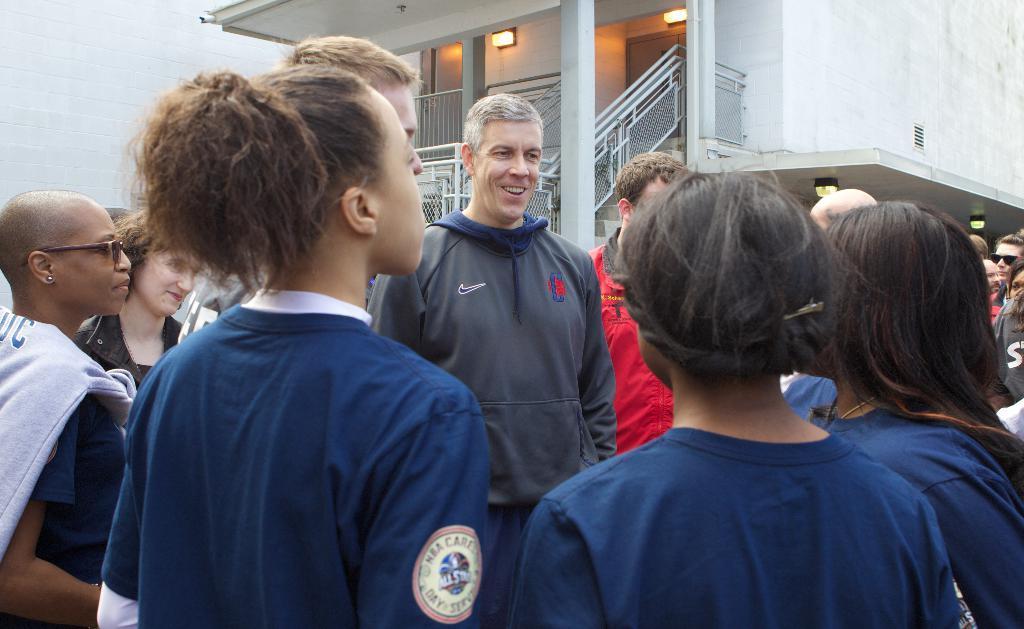In one or two sentences, can you explain what this image depicts? In this image we can see the people standing. In the background, we can see the building with the stairs, wall, door and also the lights. We can also see the building wall on the left. 